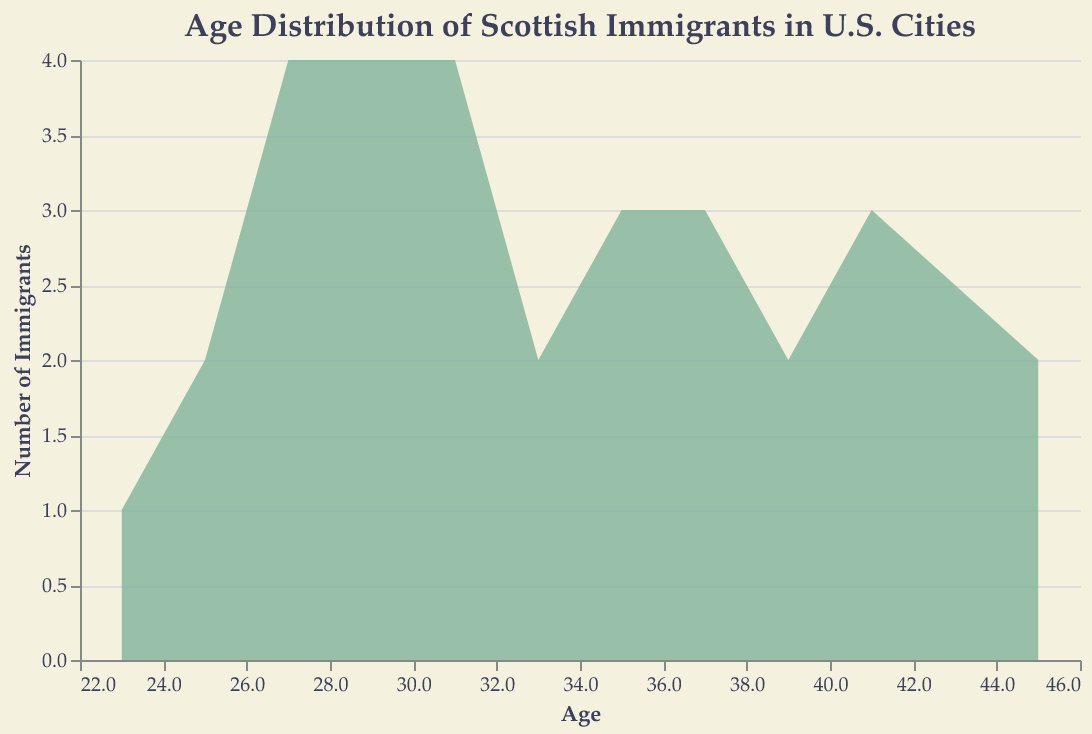What is the title of the figure? The title of the figure can be seen at the top.
Answer: Age Distribution of Scottish Immigrants in U.S. Cities What is the x-axis representing? The x-axis represents the ages of the Scottish immigrants.
Answer: Age Which city has the youngest immigrant shown in the data? By examining the data points, the youngest age, 22, is associated with Seattle.
Answer: Seattle How many cities are represented in the figure? By counting the unique city names, we can determine there are 8 distinct cities.
Answer: 8 What does the y-axis represent? The y-axis represents the number of immigrants.
Answer: Number of Immigrants Based on the visual representation, which age group has the highest number of immigrants? By looking at the highest point on the y-axis, the age group around 30 appears to have the most immigrants.
Answer: Around age 30 Are there more immigrants aged 25 or 40? By comparing the heights of the areas at ages 25 and 40, there are more immigrants aged 40.
Answer: Age 40 Which city has the largest range in the ages of immigrants? By comparing the minimum and maximum ages, San Francisco ranges from 27 to 45, which is the largest difference of 18 years.
Answer: San Francisco In which age bin does the count of immigrants from Chicago peak? The peak count can be identified around the age group 35-40.
Answer: 35-40 Comparing immigrants in their 20s to those in their 40s, which group is larger across all cities? By adding the counts of all immigrants in their 20s and their 40s, the 20s group appears to be larger.
Answer: 20s 